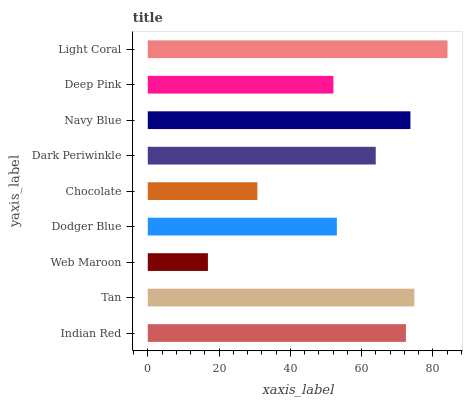Is Web Maroon the minimum?
Answer yes or no. Yes. Is Light Coral the maximum?
Answer yes or no. Yes. Is Tan the minimum?
Answer yes or no. No. Is Tan the maximum?
Answer yes or no. No. Is Tan greater than Indian Red?
Answer yes or no. Yes. Is Indian Red less than Tan?
Answer yes or no. Yes. Is Indian Red greater than Tan?
Answer yes or no. No. Is Tan less than Indian Red?
Answer yes or no. No. Is Dark Periwinkle the high median?
Answer yes or no. Yes. Is Dark Periwinkle the low median?
Answer yes or no. Yes. Is Deep Pink the high median?
Answer yes or no. No. Is Web Maroon the low median?
Answer yes or no. No. 